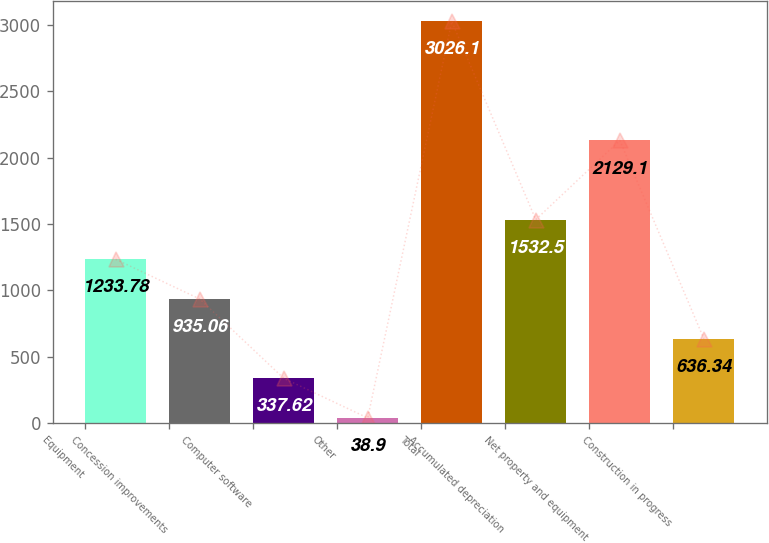Convert chart to OTSL. <chart><loc_0><loc_0><loc_500><loc_500><bar_chart><fcel>Equipment<fcel>Concession improvements<fcel>Computer software<fcel>Other<fcel>Total<fcel>Accumulated depreciation<fcel>Net property and equipment<fcel>Construction in progress<nl><fcel>1233.78<fcel>935.06<fcel>337.62<fcel>38.9<fcel>3026.1<fcel>1532.5<fcel>2129.1<fcel>636.34<nl></chart> 